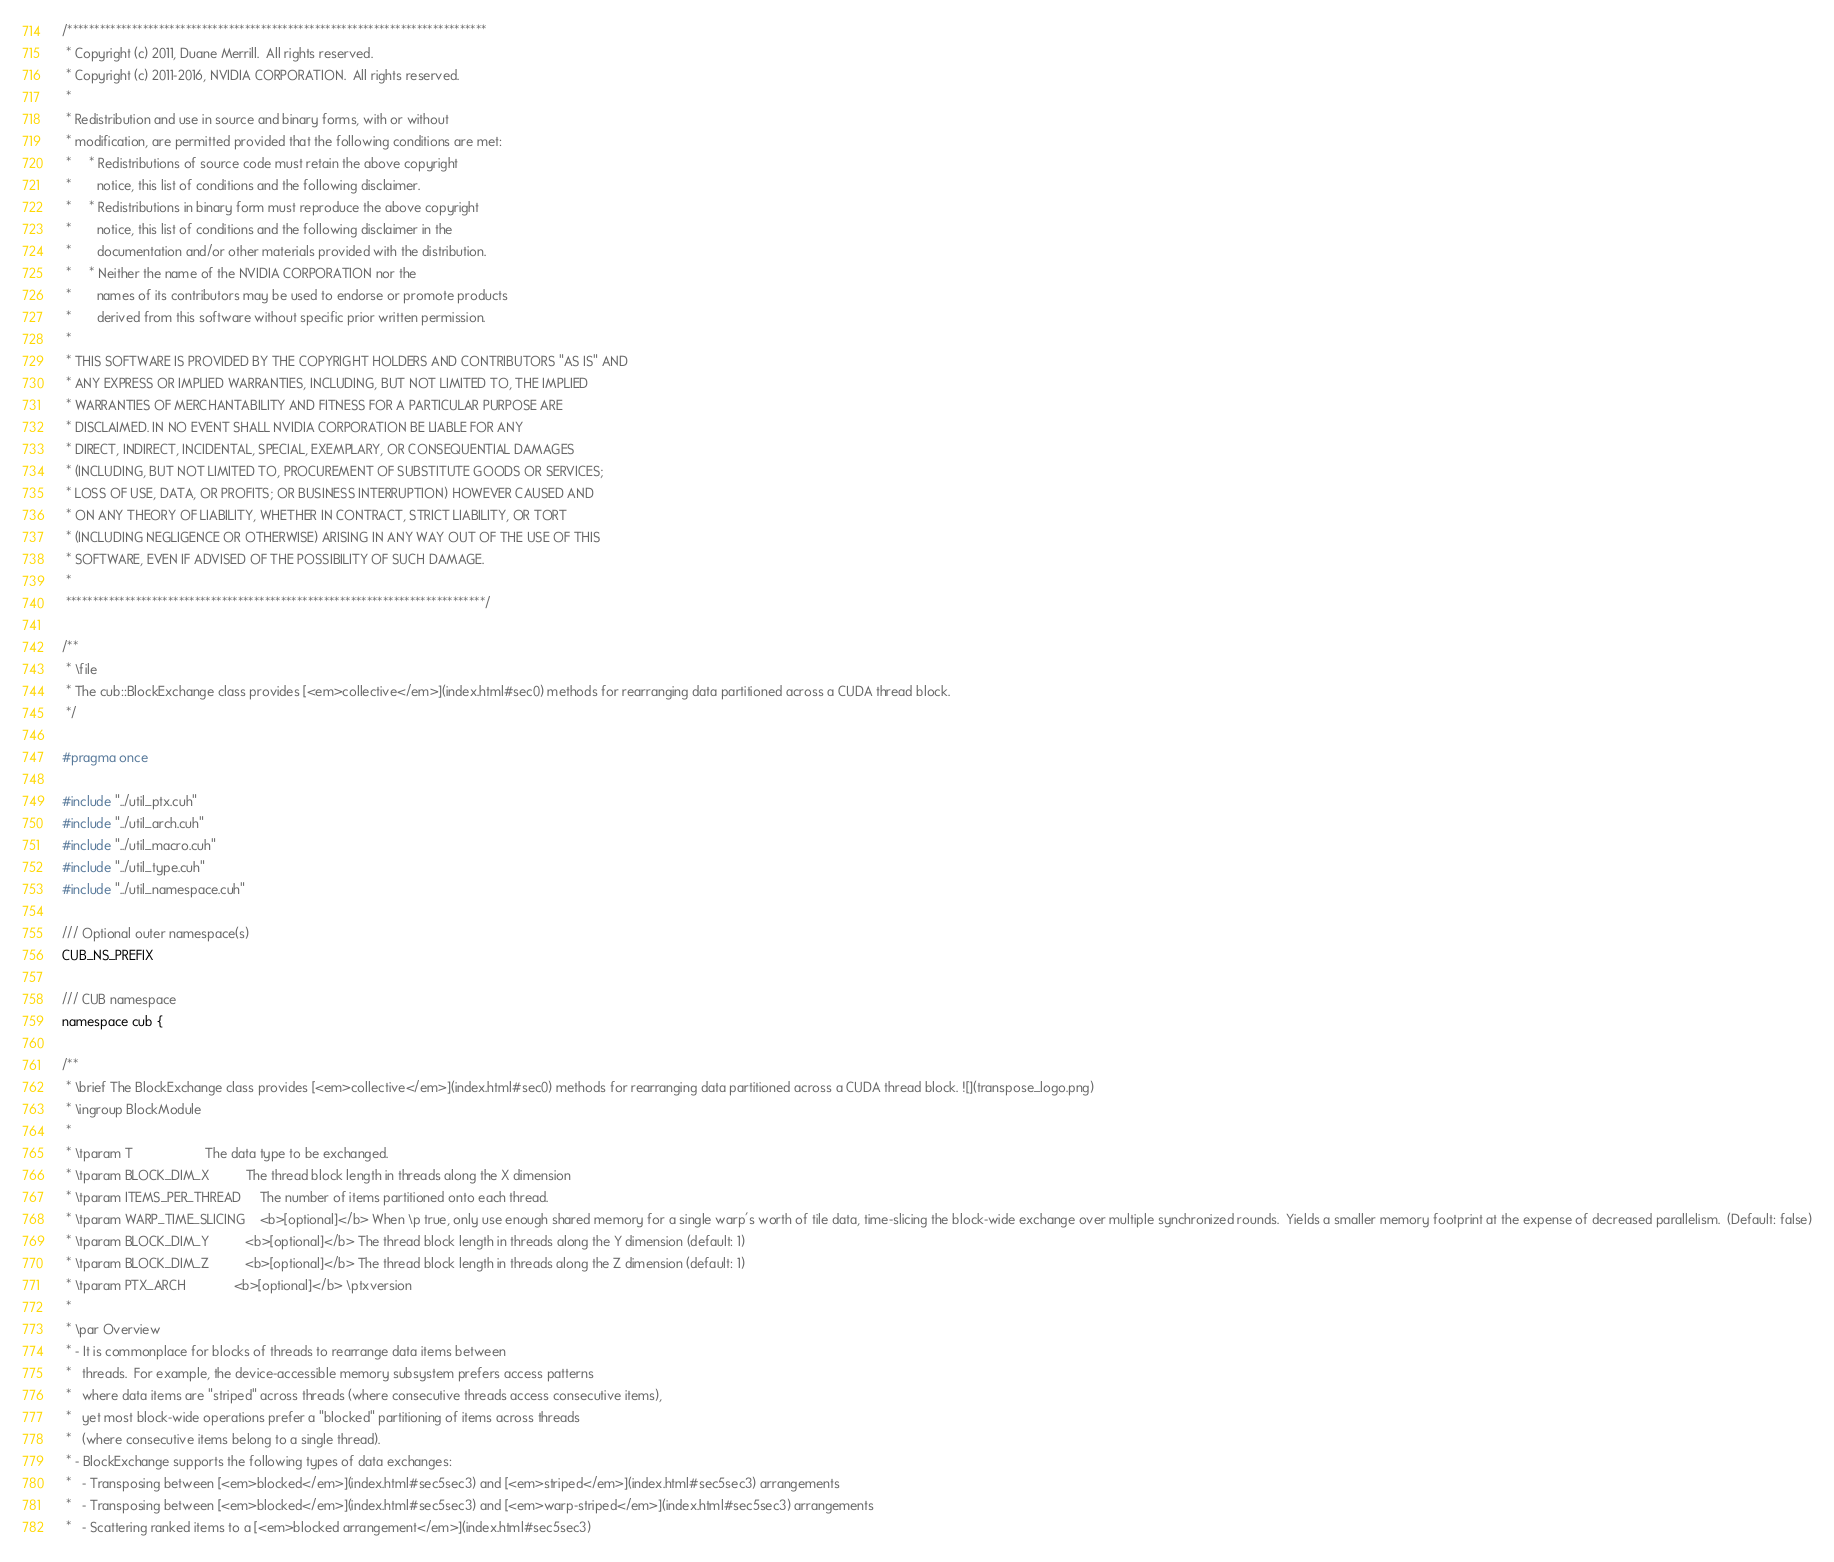Convert code to text. <code><loc_0><loc_0><loc_500><loc_500><_Cuda_>/******************************************************************************
 * Copyright (c) 2011, Duane Merrill.  All rights reserved.
 * Copyright (c) 2011-2016, NVIDIA CORPORATION.  All rights reserved.
 * 
 * Redistribution and use in source and binary forms, with or without
 * modification, are permitted provided that the following conditions are met:
 *     * Redistributions of source code must retain the above copyright
 *       notice, this list of conditions and the following disclaimer.
 *     * Redistributions in binary form must reproduce the above copyright
 *       notice, this list of conditions and the following disclaimer in the
 *       documentation and/or other materials provided with the distribution.
 *     * Neither the name of the NVIDIA CORPORATION nor the
 *       names of its contributors may be used to endorse or promote products
 *       derived from this software without specific prior written permission.
 * 
 * THIS SOFTWARE IS PROVIDED BY THE COPYRIGHT HOLDERS AND CONTRIBUTORS "AS IS" AND
 * ANY EXPRESS OR IMPLIED WARRANTIES, INCLUDING, BUT NOT LIMITED TO, THE IMPLIED
 * WARRANTIES OF MERCHANTABILITY AND FITNESS FOR A PARTICULAR PURPOSE ARE
 * DISCLAIMED. IN NO EVENT SHALL NVIDIA CORPORATION BE LIABLE FOR ANY
 * DIRECT, INDIRECT, INCIDENTAL, SPECIAL, EXEMPLARY, OR CONSEQUENTIAL DAMAGES
 * (INCLUDING, BUT NOT LIMITED TO, PROCUREMENT OF SUBSTITUTE GOODS OR SERVICES;
 * LOSS OF USE, DATA, OR PROFITS; OR BUSINESS INTERRUPTION) HOWEVER CAUSED AND
 * ON ANY THEORY OF LIABILITY, WHETHER IN CONTRACT, STRICT LIABILITY, OR TORT
 * (INCLUDING NEGLIGENCE OR OTHERWISE) ARISING IN ANY WAY OUT OF THE USE OF THIS
 * SOFTWARE, EVEN IF ADVISED OF THE POSSIBILITY OF SUCH DAMAGE.
 *
 ******************************************************************************/

/**
 * \file
 * The cub::BlockExchange class provides [<em>collective</em>](index.html#sec0) methods for rearranging data partitioned across a CUDA thread block.
 */

#pragma once

#include "../util_ptx.cuh"
#include "../util_arch.cuh"
#include "../util_macro.cuh"
#include "../util_type.cuh"
#include "../util_namespace.cuh"

/// Optional outer namespace(s)
CUB_NS_PREFIX

/// CUB namespace
namespace cub {

/**
 * \brief The BlockExchange class provides [<em>collective</em>](index.html#sec0) methods for rearranging data partitioned across a CUDA thread block. ![](transpose_logo.png)
 * \ingroup BlockModule
 *
 * \tparam T                    The data type to be exchanged.
 * \tparam BLOCK_DIM_X          The thread block length in threads along the X dimension
 * \tparam ITEMS_PER_THREAD     The number of items partitioned onto each thread.
 * \tparam WARP_TIME_SLICING    <b>[optional]</b> When \p true, only use enough shared memory for a single warp's worth of tile data, time-slicing the block-wide exchange over multiple synchronized rounds.  Yields a smaller memory footprint at the expense of decreased parallelism.  (Default: false)
 * \tparam BLOCK_DIM_Y          <b>[optional]</b> The thread block length in threads along the Y dimension (default: 1)
 * \tparam BLOCK_DIM_Z          <b>[optional]</b> The thread block length in threads along the Z dimension (default: 1)
 * \tparam PTX_ARCH             <b>[optional]</b> \ptxversion
 *
 * \par Overview
 * - It is commonplace for blocks of threads to rearrange data items between
 *   threads.  For example, the device-accessible memory subsystem prefers access patterns
 *   where data items are "striped" across threads (where consecutive threads access consecutive items),
 *   yet most block-wide operations prefer a "blocked" partitioning of items across threads
 *   (where consecutive items belong to a single thread).
 * - BlockExchange supports the following types of data exchanges:
 *   - Transposing between [<em>blocked</em>](index.html#sec5sec3) and [<em>striped</em>](index.html#sec5sec3) arrangements
 *   - Transposing between [<em>blocked</em>](index.html#sec5sec3) and [<em>warp-striped</em>](index.html#sec5sec3) arrangements
 *   - Scattering ranked items to a [<em>blocked arrangement</em>](index.html#sec5sec3)</code> 